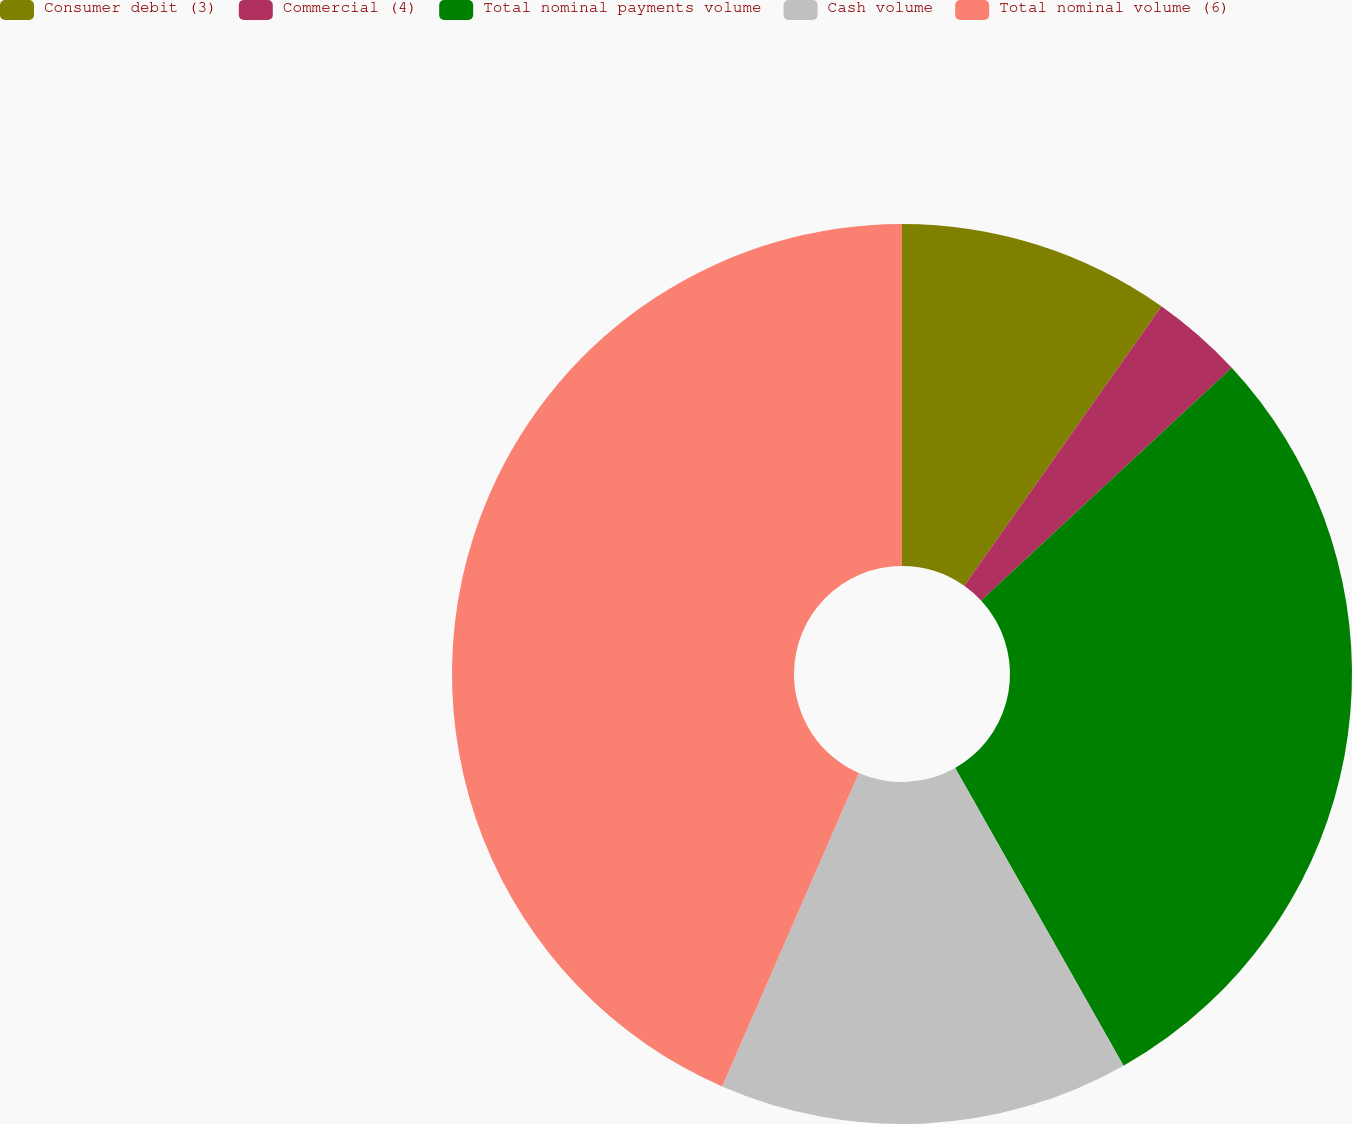Convert chart. <chart><loc_0><loc_0><loc_500><loc_500><pie_chart><fcel>Consumer debit (3)<fcel>Commercial (4)<fcel>Total nominal payments volume<fcel>Cash volume<fcel>Total nominal volume (6)<nl><fcel>9.78%<fcel>3.31%<fcel>28.72%<fcel>14.74%<fcel>43.46%<nl></chart> 